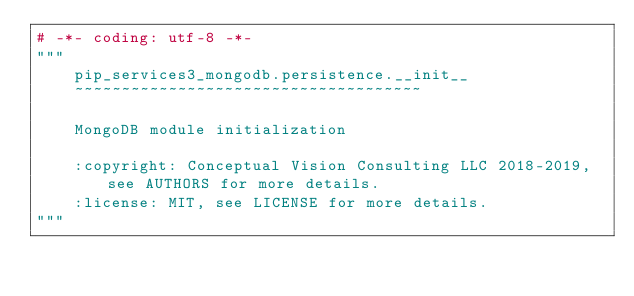<code> <loc_0><loc_0><loc_500><loc_500><_Python_># -*- coding: utf-8 -*-
"""
    pip_services3_mongodb.persistence.__init__
    ~~~~~~~~~~~~~~~~~~~~~~~~~~~~~~~~~~~~~
    
    MongoDB module initialization
    
    :copyright: Conceptual Vision Consulting LLC 2018-2019, see AUTHORS for more details.
    :license: MIT, see LICENSE for more details.
"""
</code> 